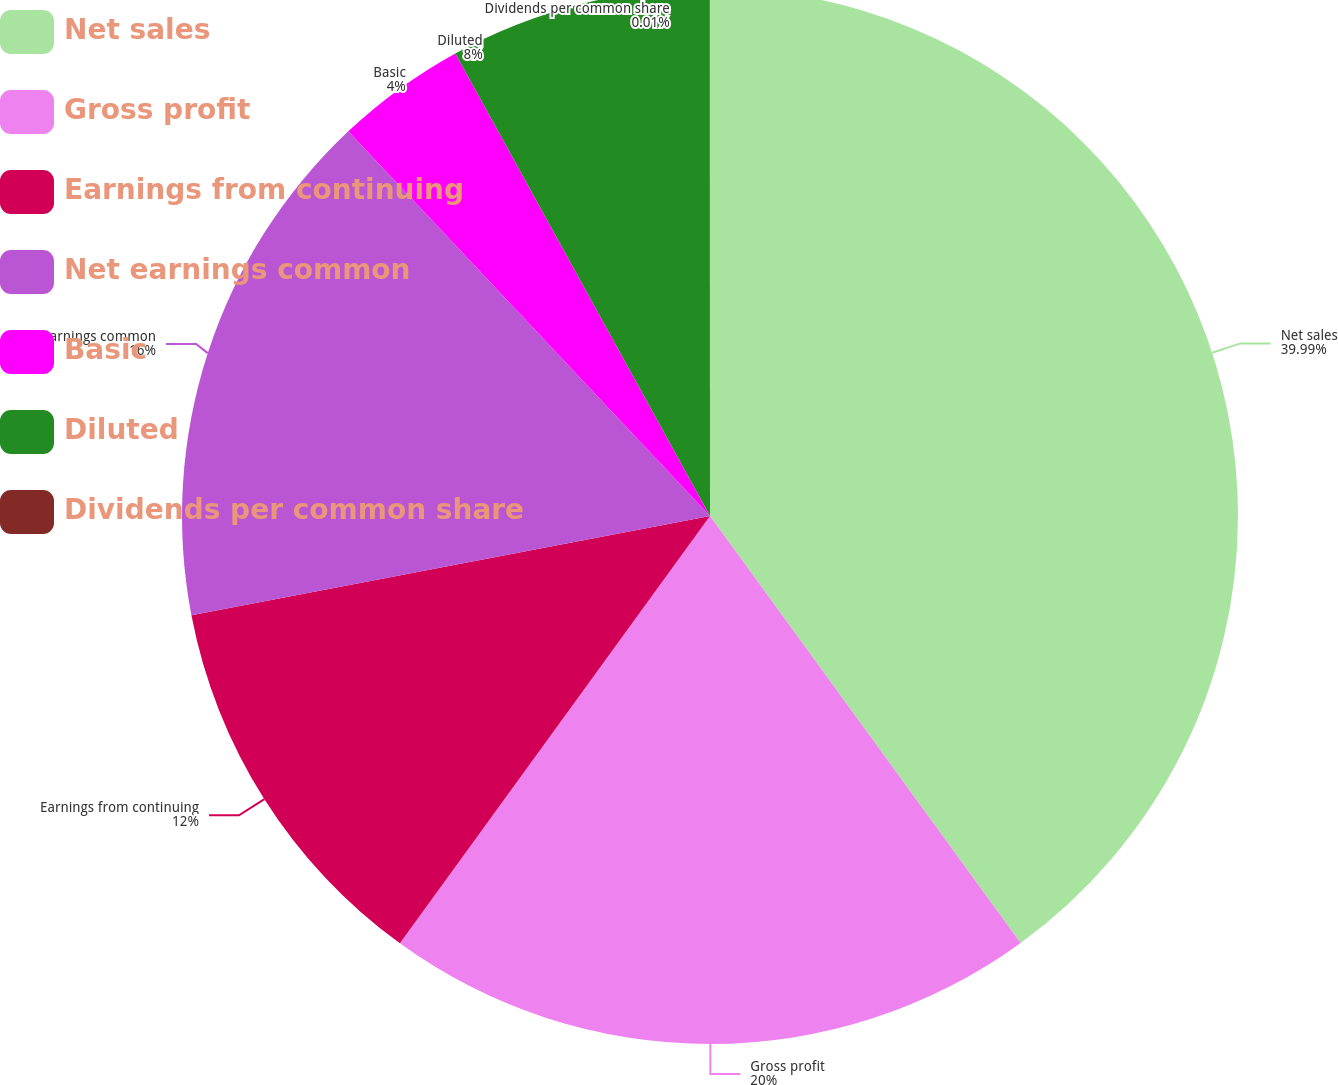<chart> <loc_0><loc_0><loc_500><loc_500><pie_chart><fcel>Net sales<fcel>Gross profit<fcel>Earnings from continuing<fcel>Net earnings common<fcel>Basic<fcel>Diluted<fcel>Dividends per common share<nl><fcel>39.99%<fcel>20.0%<fcel>12.0%<fcel>16.0%<fcel>4.0%<fcel>8.0%<fcel>0.01%<nl></chart> 